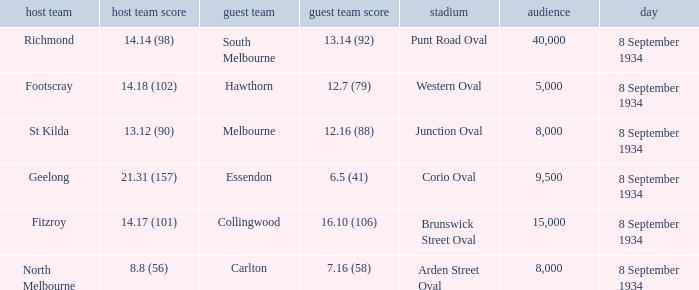When the Venue was Punt Road Oval, who was the Home Team? Richmond. 